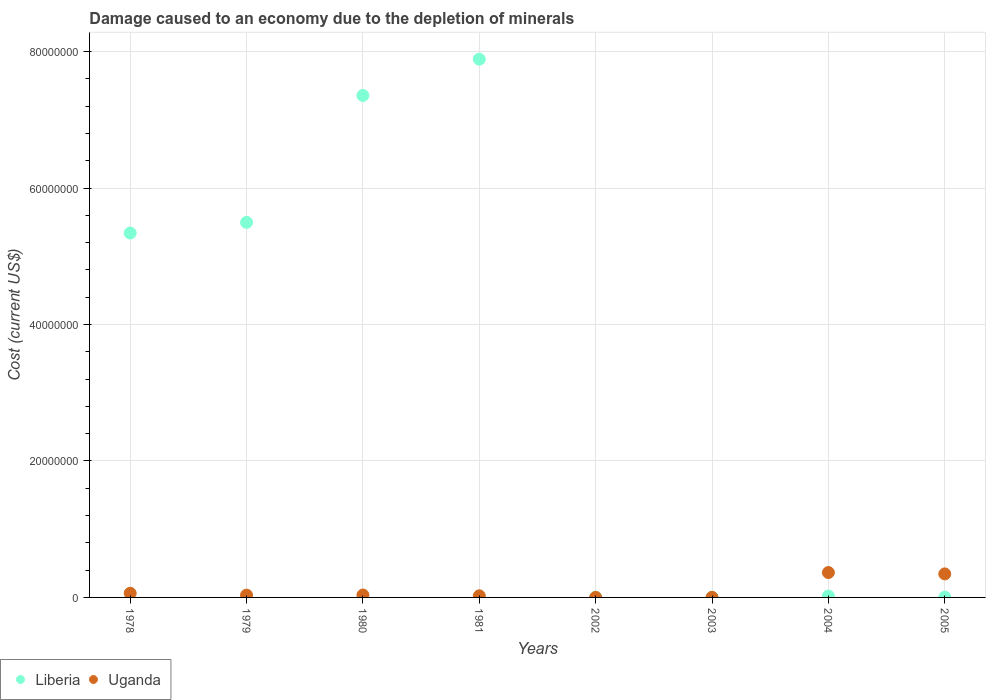What is the cost of damage caused due to the depletion of minerals in Uganda in 2005?
Your answer should be compact. 3.45e+06. Across all years, what is the maximum cost of damage caused due to the depletion of minerals in Uganda?
Your answer should be very brief. 3.65e+06. Across all years, what is the minimum cost of damage caused due to the depletion of minerals in Liberia?
Offer a very short reply. 2.69e+04. What is the total cost of damage caused due to the depletion of minerals in Uganda in the graph?
Your answer should be very brief. 8.64e+06. What is the difference between the cost of damage caused due to the depletion of minerals in Uganda in 1980 and that in 2004?
Your response must be concise. -3.29e+06. What is the difference between the cost of damage caused due to the depletion of minerals in Uganda in 1978 and the cost of damage caused due to the depletion of minerals in Liberia in 2005?
Make the answer very short. 5.67e+05. What is the average cost of damage caused due to the depletion of minerals in Liberia per year?
Offer a very short reply. 3.26e+07. In the year 1979, what is the difference between the cost of damage caused due to the depletion of minerals in Uganda and cost of damage caused due to the depletion of minerals in Liberia?
Provide a succinct answer. -5.46e+07. What is the ratio of the cost of damage caused due to the depletion of minerals in Uganda in 1979 to that in 1980?
Provide a short and direct response. 0.95. What is the difference between the highest and the second highest cost of damage caused due to the depletion of minerals in Liberia?
Give a very brief answer. 5.32e+06. What is the difference between the highest and the lowest cost of damage caused due to the depletion of minerals in Uganda?
Your answer should be compact. 3.64e+06. How many years are there in the graph?
Provide a succinct answer. 8. Are the values on the major ticks of Y-axis written in scientific E-notation?
Offer a terse response. No. Does the graph contain grids?
Provide a short and direct response. Yes. Where does the legend appear in the graph?
Provide a short and direct response. Bottom left. How many legend labels are there?
Your answer should be compact. 2. How are the legend labels stacked?
Provide a succinct answer. Horizontal. What is the title of the graph?
Offer a very short reply. Damage caused to an economy due to the depletion of minerals. Does "Solomon Islands" appear as one of the legend labels in the graph?
Ensure brevity in your answer.  No. What is the label or title of the X-axis?
Offer a terse response. Years. What is the label or title of the Y-axis?
Make the answer very short. Cost (current US$). What is the Cost (current US$) in Liberia in 1978?
Ensure brevity in your answer.  5.34e+07. What is the Cost (current US$) of Uganda in 1978?
Offer a very short reply. 6.10e+05. What is the Cost (current US$) of Liberia in 1979?
Your answer should be very brief. 5.50e+07. What is the Cost (current US$) in Uganda in 1979?
Provide a succinct answer. 3.36e+05. What is the Cost (current US$) of Liberia in 1980?
Ensure brevity in your answer.  7.36e+07. What is the Cost (current US$) of Uganda in 1980?
Provide a short and direct response. 3.54e+05. What is the Cost (current US$) of Liberia in 1981?
Your answer should be very brief. 7.89e+07. What is the Cost (current US$) of Uganda in 1981?
Offer a very short reply. 2.35e+05. What is the Cost (current US$) in Liberia in 2002?
Your response must be concise. 2.81e+04. What is the Cost (current US$) in Uganda in 2002?
Your answer should be compact. 4439.92. What is the Cost (current US$) in Liberia in 2003?
Provide a succinct answer. 2.69e+04. What is the Cost (current US$) in Uganda in 2003?
Offer a terse response. 9801.46. What is the Cost (current US$) of Liberia in 2004?
Offer a terse response. 2.06e+05. What is the Cost (current US$) of Uganda in 2004?
Ensure brevity in your answer.  3.65e+06. What is the Cost (current US$) of Liberia in 2005?
Offer a very short reply. 4.30e+04. What is the Cost (current US$) of Uganda in 2005?
Ensure brevity in your answer.  3.45e+06. Across all years, what is the maximum Cost (current US$) of Liberia?
Keep it short and to the point. 7.89e+07. Across all years, what is the maximum Cost (current US$) in Uganda?
Offer a terse response. 3.65e+06. Across all years, what is the minimum Cost (current US$) of Liberia?
Provide a succinct answer. 2.69e+04. Across all years, what is the minimum Cost (current US$) in Uganda?
Give a very brief answer. 4439.92. What is the total Cost (current US$) in Liberia in the graph?
Keep it short and to the point. 2.61e+08. What is the total Cost (current US$) in Uganda in the graph?
Offer a very short reply. 8.64e+06. What is the difference between the Cost (current US$) of Liberia in 1978 and that in 1979?
Offer a very short reply. -1.56e+06. What is the difference between the Cost (current US$) in Uganda in 1978 and that in 1979?
Your answer should be very brief. 2.74e+05. What is the difference between the Cost (current US$) of Liberia in 1978 and that in 1980?
Give a very brief answer. -2.02e+07. What is the difference between the Cost (current US$) of Uganda in 1978 and that in 1980?
Your answer should be very brief. 2.56e+05. What is the difference between the Cost (current US$) of Liberia in 1978 and that in 1981?
Ensure brevity in your answer.  -2.55e+07. What is the difference between the Cost (current US$) in Uganda in 1978 and that in 1981?
Your response must be concise. 3.76e+05. What is the difference between the Cost (current US$) of Liberia in 1978 and that in 2002?
Offer a terse response. 5.34e+07. What is the difference between the Cost (current US$) of Uganda in 1978 and that in 2002?
Ensure brevity in your answer.  6.06e+05. What is the difference between the Cost (current US$) in Liberia in 1978 and that in 2003?
Your response must be concise. 5.34e+07. What is the difference between the Cost (current US$) of Uganda in 1978 and that in 2003?
Provide a short and direct response. 6.00e+05. What is the difference between the Cost (current US$) of Liberia in 1978 and that in 2004?
Your answer should be compact. 5.32e+07. What is the difference between the Cost (current US$) of Uganda in 1978 and that in 2004?
Offer a terse response. -3.04e+06. What is the difference between the Cost (current US$) in Liberia in 1978 and that in 2005?
Make the answer very short. 5.34e+07. What is the difference between the Cost (current US$) in Uganda in 1978 and that in 2005?
Ensure brevity in your answer.  -2.84e+06. What is the difference between the Cost (current US$) in Liberia in 1979 and that in 1980?
Make the answer very short. -1.86e+07. What is the difference between the Cost (current US$) in Uganda in 1979 and that in 1980?
Offer a very short reply. -1.80e+04. What is the difference between the Cost (current US$) in Liberia in 1979 and that in 1981?
Offer a very short reply. -2.39e+07. What is the difference between the Cost (current US$) in Uganda in 1979 and that in 1981?
Offer a terse response. 1.01e+05. What is the difference between the Cost (current US$) of Liberia in 1979 and that in 2002?
Offer a very short reply. 5.49e+07. What is the difference between the Cost (current US$) of Uganda in 1979 and that in 2002?
Your response must be concise. 3.31e+05. What is the difference between the Cost (current US$) of Liberia in 1979 and that in 2003?
Provide a short and direct response. 5.49e+07. What is the difference between the Cost (current US$) of Uganda in 1979 and that in 2003?
Offer a very short reply. 3.26e+05. What is the difference between the Cost (current US$) in Liberia in 1979 and that in 2004?
Ensure brevity in your answer.  5.48e+07. What is the difference between the Cost (current US$) of Uganda in 1979 and that in 2004?
Keep it short and to the point. -3.31e+06. What is the difference between the Cost (current US$) in Liberia in 1979 and that in 2005?
Provide a short and direct response. 5.49e+07. What is the difference between the Cost (current US$) of Uganda in 1979 and that in 2005?
Your answer should be compact. -3.11e+06. What is the difference between the Cost (current US$) of Liberia in 1980 and that in 1981?
Make the answer very short. -5.32e+06. What is the difference between the Cost (current US$) in Uganda in 1980 and that in 1981?
Ensure brevity in your answer.  1.19e+05. What is the difference between the Cost (current US$) of Liberia in 1980 and that in 2002?
Offer a terse response. 7.35e+07. What is the difference between the Cost (current US$) of Uganda in 1980 and that in 2002?
Your response must be concise. 3.49e+05. What is the difference between the Cost (current US$) in Liberia in 1980 and that in 2003?
Ensure brevity in your answer.  7.35e+07. What is the difference between the Cost (current US$) of Uganda in 1980 and that in 2003?
Your response must be concise. 3.44e+05. What is the difference between the Cost (current US$) of Liberia in 1980 and that in 2004?
Offer a terse response. 7.34e+07. What is the difference between the Cost (current US$) of Uganda in 1980 and that in 2004?
Give a very brief answer. -3.29e+06. What is the difference between the Cost (current US$) in Liberia in 1980 and that in 2005?
Keep it short and to the point. 7.35e+07. What is the difference between the Cost (current US$) in Uganda in 1980 and that in 2005?
Offer a terse response. -3.09e+06. What is the difference between the Cost (current US$) of Liberia in 1981 and that in 2002?
Give a very brief answer. 7.89e+07. What is the difference between the Cost (current US$) in Uganda in 1981 and that in 2002?
Keep it short and to the point. 2.30e+05. What is the difference between the Cost (current US$) of Liberia in 1981 and that in 2003?
Give a very brief answer. 7.89e+07. What is the difference between the Cost (current US$) in Uganda in 1981 and that in 2003?
Give a very brief answer. 2.25e+05. What is the difference between the Cost (current US$) of Liberia in 1981 and that in 2004?
Provide a short and direct response. 7.87e+07. What is the difference between the Cost (current US$) of Uganda in 1981 and that in 2004?
Give a very brief answer. -3.41e+06. What is the difference between the Cost (current US$) of Liberia in 1981 and that in 2005?
Offer a terse response. 7.89e+07. What is the difference between the Cost (current US$) of Uganda in 1981 and that in 2005?
Offer a very short reply. -3.21e+06. What is the difference between the Cost (current US$) in Liberia in 2002 and that in 2003?
Provide a short and direct response. 1239.24. What is the difference between the Cost (current US$) of Uganda in 2002 and that in 2003?
Offer a terse response. -5361.53. What is the difference between the Cost (current US$) in Liberia in 2002 and that in 2004?
Offer a terse response. -1.78e+05. What is the difference between the Cost (current US$) in Uganda in 2002 and that in 2004?
Make the answer very short. -3.64e+06. What is the difference between the Cost (current US$) of Liberia in 2002 and that in 2005?
Your answer should be very brief. -1.48e+04. What is the difference between the Cost (current US$) in Uganda in 2002 and that in 2005?
Provide a short and direct response. -3.44e+06. What is the difference between the Cost (current US$) of Liberia in 2003 and that in 2004?
Your answer should be very brief. -1.79e+05. What is the difference between the Cost (current US$) in Uganda in 2003 and that in 2004?
Offer a terse response. -3.64e+06. What is the difference between the Cost (current US$) of Liberia in 2003 and that in 2005?
Make the answer very short. -1.61e+04. What is the difference between the Cost (current US$) in Uganda in 2003 and that in 2005?
Ensure brevity in your answer.  -3.44e+06. What is the difference between the Cost (current US$) of Liberia in 2004 and that in 2005?
Offer a very short reply. 1.63e+05. What is the difference between the Cost (current US$) of Uganda in 2004 and that in 2005?
Provide a short and direct response. 2.01e+05. What is the difference between the Cost (current US$) of Liberia in 1978 and the Cost (current US$) of Uganda in 1979?
Provide a succinct answer. 5.31e+07. What is the difference between the Cost (current US$) of Liberia in 1978 and the Cost (current US$) of Uganda in 1980?
Give a very brief answer. 5.31e+07. What is the difference between the Cost (current US$) of Liberia in 1978 and the Cost (current US$) of Uganda in 1981?
Offer a very short reply. 5.32e+07. What is the difference between the Cost (current US$) in Liberia in 1978 and the Cost (current US$) in Uganda in 2002?
Your response must be concise. 5.34e+07. What is the difference between the Cost (current US$) of Liberia in 1978 and the Cost (current US$) of Uganda in 2003?
Provide a succinct answer. 5.34e+07. What is the difference between the Cost (current US$) in Liberia in 1978 and the Cost (current US$) in Uganda in 2004?
Your answer should be very brief. 4.98e+07. What is the difference between the Cost (current US$) in Liberia in 1978 and the Cost (current US$) in Uganda in 2005?
Offer a very short reply. 5.00e+07. What is the difference between the Cost (current US$) in Liberia in 1979 and the Cost (current US$) in Uganda in 1980?
Give a very brief answer. 5.46e+07. What is the difference between the Cost (current US$) of Liberia in 1979 and the Cost (current US$) of Uganda in 1981?
Offer a very short reply. 5.47e+07. What is the difference between the Cost (current US$) of Liberia in 1979 and the Cost (current US$) of Uganda in 2002?
Your answer should be very brief. 5.50e+07. What is the difference between the Cost (current US$) in Liberia in 1979 and the Cost (current US$) in Uganda in 2003?
Your answer should be very brief. 5.50e+07. What is the difference between the Cost (current US$) of Liberia in 1979 and the Cost (current US$) of Uganda in 2004?
Your response must be concise. 5.13e+07. What is the difference between the Cost (current US$) in Liberia in 1979 and the Cost (current US$) in Uganda in 2005?
Your answer should be very brief. 5.15e+07. What is the difference between the Cost (current US$) of Liberia in 1980 and the Cost (current US$) of Uganda in 1981?
Provide a succinct answer. 7.33e+07. What is the difference between the Cost (current US$) of Liberia in 1980 and the Cost (current US$) of Uganda in 2002?
Your response must be concise. 7.36e+07. What is the difference between the Cost (current US$) of Liberia in 1980 and the Cost (current US$) of Uganda in 2003?
Ensure brevity in your answer.  7.36e+07. What is the difference between the Cost (current US$) of Liberia in 1980 and the Cost (current US$) of Uganda in 2004?
Give a very brief answer. 6.99e+07. What is the difference between the Cost (current US$) in Liberia in 1980 and the Cost (current US$) in Uganda in 2005?
Your response must be concise. 7.01e+07. What is the difference between the Cost (current US$) in Liberia in 1981 and the Cost (current US$) in Uganda in 2002?
Offer a very short reply. 7.89e+07. What is the difference between the Cost (current US$) in Liberia in 1981 and the Cost (current US$) in Uganda in 2003?
Make the answer very short. 7.89e+07. What is the difference between the Cost (current US$) in Liberia in 1981 and the Cost (current US$) in Uganda in 2004?
Your answer should be very brief. 7.52e+07. What is the difference between the Cost (current US$) of Liberia in 1981 and the Cost (current US$) of Uganda in 2005?
Your answer should be compact. 7.54e+07. What is the difference between the Cost (current US$) of Liberia in 2002 and the Cost (current US$) of Uganda in 2003?
Keep it short and to the point. 1.83e+04. What is the difference between the Cost (current US$) of Liberia in 2002 and the Cost (current US$) of Uganda in 2004?
Offer a very short reply. -3.62e+06. What is the difference between the Cost (current US$) of Liberia in 2002 and the Cost (current US$) of Uganda in 2005?
Offer a very short reply. -3.42e+06. What is the difference between the Cost (current US$) of Liberia in 2003 and the Cost (current US$) of Uganda in 2004?
Keep it short and to the point. -3.62e+06. What is the difference between the Cost (current US$) in Liberia in 2003 and the Cost (current US$) in Uganda in 2005?
Provide a short and direct response. -3.42e+06. What is the difference between the Cost (current US$) in Liberia in 2004 and the Cost (current US$) in Uganda in 2005?
Make the answer very short. -3.24e+06. What is the average Cost (current US$) in Liberia per year?
Your response must be concise. 3.26e+07. What is the average Cost (current US$) of Uganda per year?
Your answer should be compact. 1.08e+06. In the year 1978, what is the difference between the Cost (current US$) of Liberia and Cost (current US$) of Uganda?
Give a very brief answer. 5.28e+07. In the year 1979, what is the difference between the Cost (current US$) of Liberia and Cost (current US$) of Uganda?
Your response must be concise. 5.46e+07. In the year 1980, what is the difference between the Cost (current US$) of Liberia and Cost (current US$) of Uganda?
Ensure brevity in your answer.  7.32e+07. In the year 1981, what is the difference between the Cost (current US$) in Liberia and Cost (current US$) in Uganda?
Ensure brevity in your answer.  7.87e+07. In the year 2002, what is the difference between the Cost (current US$) of Liberia and Cost (current US$) of Uganda?
Make the answer very short. 2.37e+04. In the year 2003, what is the difference between the Cost (current US$) in Liberia and Cost (current US$) in Uganda?
Keep it short and to the point. 1.71e+04. In the year 2004, what is the difference between the Cost (current US$) of Liberia and Cost (current US$) of Uganda?
Make the answer very short. -3.44e+06. In the year 2005, what is the difference between the Cost (current US$) of Liberia and Cost (current US$) of Uganda?
Your response must be concise. -3.40e+06. What is the ratio of the Cost (current US$) in Liberia in 1978 to that in 1979?
Your answer should be very brief. 0.97. What is the ratio of the Cost (current US$) of Uganda in 1978 to that in 1979?
Provide a short and direct response. 1.82. What is the ratio of the Cost (current US$) of Liberia in 1978 to that in 1980?
Your answer should be very brief. 0.73. What is the ratio of the Cost (current US$) in Uganda in 1978 to that in 1980?
Your answer should be very brief. 1.72. What is the ratio of the Cost (current US$) of Liberia in 1978 to that in 1981?
Make the answer very short. 0.68. What is the ratio of the Cost (current US$) of Uganda in 1978 to that in 1981?
Your answer should be very brief. 2.6. What is the ratio of the Cost (current US$) in Liberia in 1978 to that in 2002?
Give a very brief answer. 1898.21. What is the ratio of the Cost (current US$) of Uganda in 1978 to that in 2002?
Give a very brief answer. 137.44. What is the ratio of the Cost (current US$) in Liberia in 1978 to that in 2003?
Give a very brief answer. 1985.66. What is the ratio of the Cost (current US$) in Uganda in 1978 to that in 2003?
Your answer should be very brief. 62.26. What is the ratio of the Cost (current US$) in Liberia in 1978 to that in 2004?
Make the answer very short. 259.14. What is the ratio of the Cost (current US$) of Uganda in 1978 to that in 2004?
Keep it short and to the point. 0.17. What is the ratio of the Cost (current US$) in Liberia in 1978 to that in 2005?
Provide a succinct answer. 1243.46. What is the ratio of the Cost (current US$) in Uganda in 1978 to that in 2005?
Your answer should be compact. 0.18. What is the ratio of the Cost (current US$) of Liberia in 1979 to that in 1980?
Ensure brevity in your answer.  0.75. What is the ratio of the Cost (current US$) of Uganda in 1979 to that in 1980?
Offer a very short reply. 0.95. What is the ratio of the Cost (current US$) of Liberia in 1979 to that in 1981?
Offer a very short reply. 0.7. What is the ratio of the Cost (current US$) in Uganda in 1979 to that in 1981?
Give a very brief answer. 1.43. What is the ratio of the Cost (current US$) of Liberia in 1979 to that in 2002?
Your response must be concise. 1953.81. What is the ratio of the Cost (current US$) in Uganda in 1979 to that in 2002?
Give a very brief answer. 75.62. What is the ratio of the Cost (current US$) in Liberia in 1979 to that in 2003?
Ensure brevity in your answer.  2043.83. What is the ratio of the Cost (current US$) in Uganda in 1979 to that in 2003?
Your answer should be compact. 34.26. What is the ratio of the Cost (current US$) in Liberia in 1979 to that in 2004?
Give a very brief answer. 266.73. What is the ratio of the Cost (current US$) in Uganda in 1979 to that in 2004?
Your answer should be compact. 0.09. What is the ratio of the Cost (current US$) in Liberia in 1979 to that in 2005?
Keep it short and to the point. 1279.88. What is the ratio of the Cost (current US$) of Uganda in 1979 to that in 2005?
Provide a short and direct response. 0.1. What is the ratio of the Cost (current US$) in Liberia in 1980 to that in 1981?
Offer a very short reply. 0.93. What is the ratio of the Cost (current US$) of Uganda in 1980 to that in 1981?
Make the answer very short. 1.51. What is the ratio of the Cost (current US$) in Liberia in 1980 to that in 2002?
Make the answer very short. 2614.82. What is the ratio of the Cost (current US$) of Uganda in 1980 to that in 2002?
Offer a terse response. 79.68. What is the ratio of the Cost (current US$) in Liberia in 1980 to that in 2003?
Ensure brevity in your answer.  2735.3. What is the ratio of the Cost (current US$) of Uganda in 1980 to that in 2003?
Provide a succinct answer. 36.09. What is the ratio of the Cost (current US$) of Liberia in 1980 to that in 2004?
Your answer should be compact. 356.97. What is the ratio of the Cost (current US$) of Uganda in 1980 to that in 2004?
Offer a terse response. 0.1. What is the ratio of the Cost (current US$) in Liberia in 1980 to that in 2005?
Offer a very short reply. 1712.89. What is the ratio of the Cost (current US$) of Uganda in 1980 to that in 2005?
Provide a short and direct response. 0.1. What is the ratio of the Cost (current US$) of Liberia in 1981 to that in 2002?
Your answer should be compact. 2804.05. What is the ratio of the Cost (current US$) of Uganda in 1981 to that in 2002?
Make the answer very short. 52.83. What is the ratio of the Cost (current US$) of Liberia in 1981 to that in 2003?
Provide a succinct answer. 2933.24. What is the ratio of the Cost (current US$) of Uganda in 1981 to that in 2003?
Your response must be concise. 23.93. What is the ratio of the Cost (current US$) in Liberia in 1981 to that in 2004?
Keep it short and to the point. 382.8. What is the ratio of the Cost (current US$) of Uganda in 1981 to that in 2004?
Keep it short and to the point. 0.06. What is the ratio of the Cost (current US$) of Liberia in 1981 to that in 2005?
Your response must be concise. 1836.84. What is the ratio of the Cost (current US$) in Uganda in 1981 to that in 2005?
Provide a succinct answer. 0.07. What is the ratio of the Cost (current US$) of Liberia in 2002 to that in 2003?
Your answer should be compact. 1.05. What is the ratio of the Cost (current US$) of Uganda in 2002 to that in 2003?
Give a very brief answer. 0.45. What is the ratio of the Cost (current US$) in Liberia in 2002 to that in 2004?
Make the answer very short. 0.14. What is the ratio of the Cost (current US$) of Uganda in 2002 to that in 2004?
Make the answer very short. 0. What is the ratio of the Cost (current US$) of Liberia in 2002 to that in 2005?
Keep it short and to the point. 0.66. What is the ratio of the Cost (current US$) of Uganda in 2002 to that in 2005?
Keep it short and to the point. 0. What is the ratio of the Cost (current US$) of Liberia in 2003 to that in 2004?
Offer a very short reply. 0.13. What is the ratio of the Cost (current US$) of Uganda in 2003 to that in 2004?
Make the answer very short. 0. What is the ratio of the Cost (current US$) in Liberia in 2003 to that in 2005?
Provide a succinct answer. 0.63. What is the ratio of the Cost (current US$) of Uganda in 2003 to that in 2005?
Provide a succinct answer. 0. What is the ratio of the Cost (current US$) of Liberia in 2004 to that in 2005?
Make the answer very short. 4.8. What is the ratio of the Cost (current US$) in Uganda in 2004 to that in 2005?
Your response must be concise. 1.06. What is the difference between the highest and the second highest Cost (current US$) of Liberia?
Keep it short and to the point. 5.32e+06. What is the difference between the highest and the second highest Cost (current US$) of Uganda?
Your answer should be compact. 2.01e+05. What is the difference between the highest and the lowest Cost (current US$) in Liberia?
Offer a very short reply. 7.89e+07. What is the difference between the highest and the lowest Cost (current US$) of Uganda?
Provide a succinct answer. 3.64e+06. 